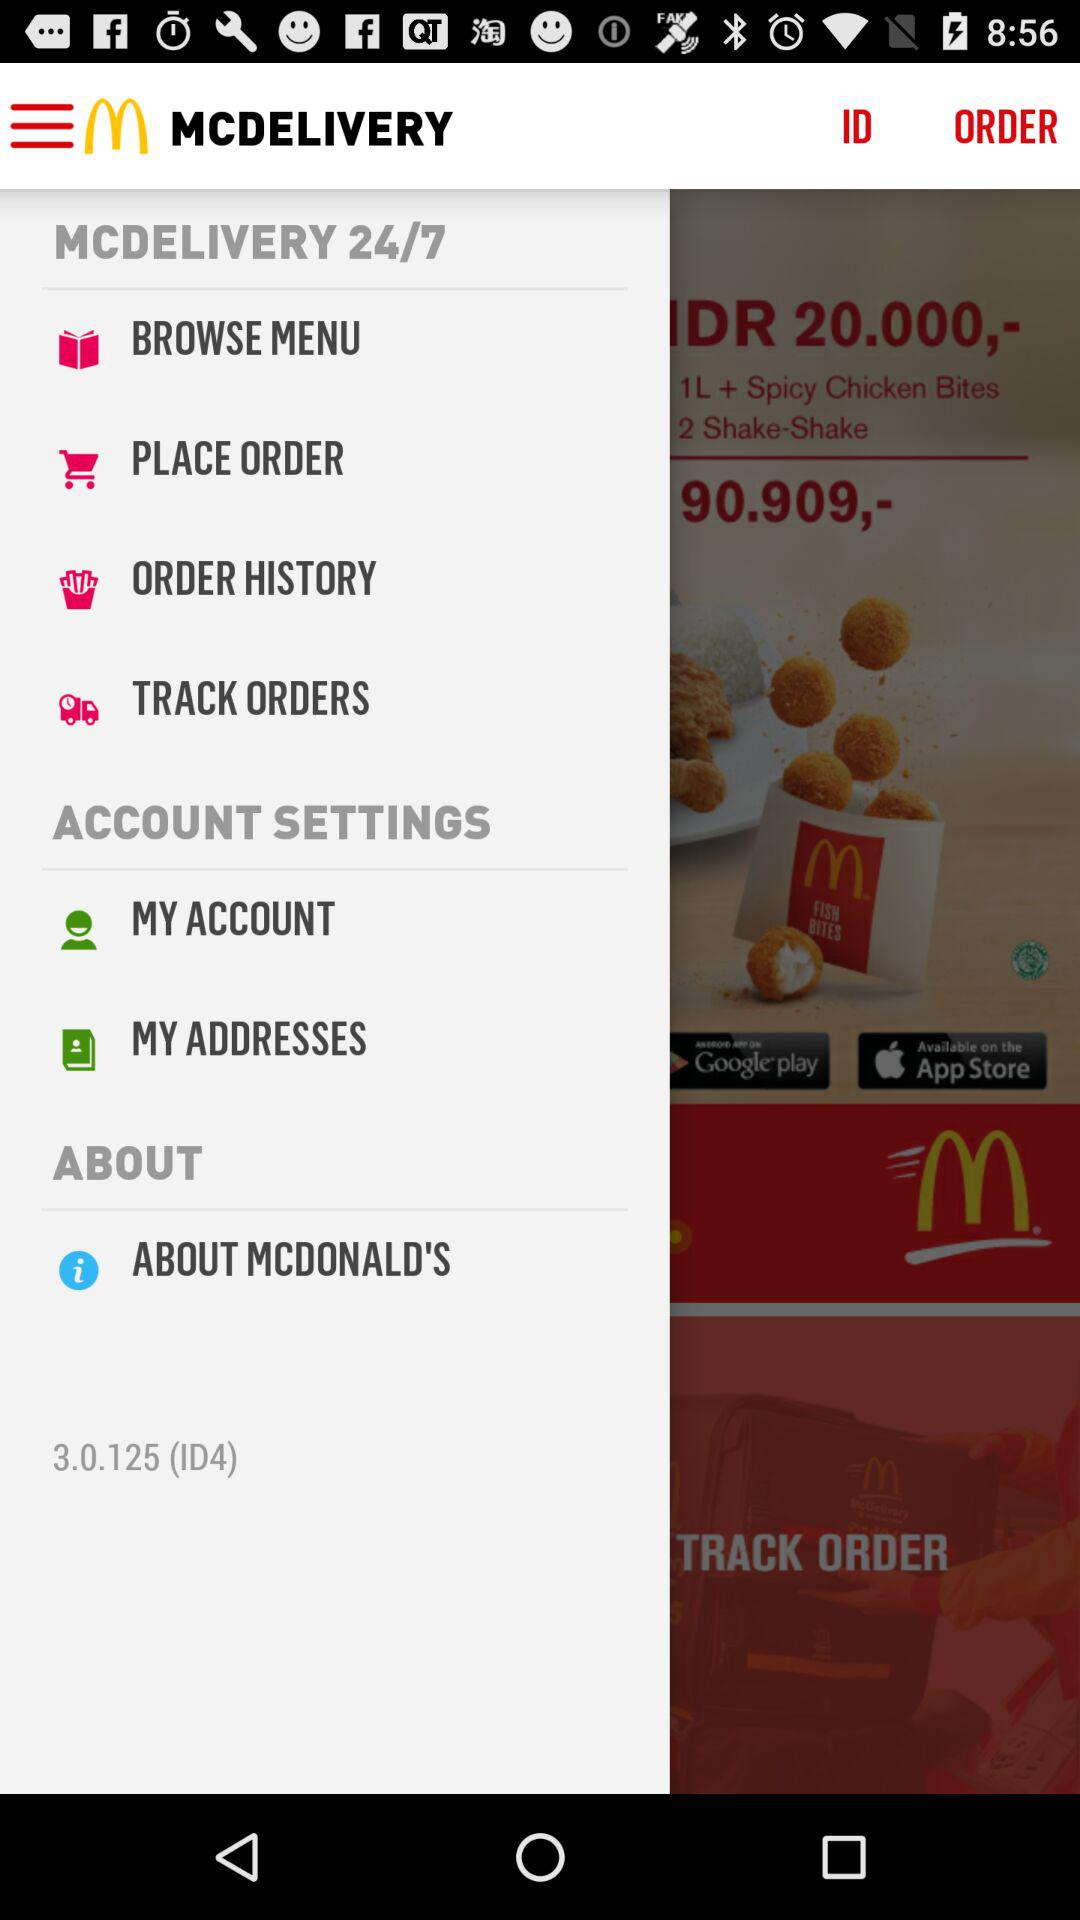What is the name of the application? The name of the application is "MCDELIVERY". 